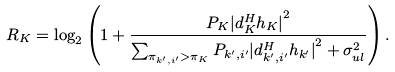Convert formula to latex. <formula><loc_0><loc_0><loc_500><loc_500>R _ { K } = \log _ { 2 } \left ( 1 + \frac { P _ { K } { | d _ { K } ^ { H } h _ { K } | } ^ { 2 } } { \sum _ { \pi _ { k ^ { \prime } , i ^ { \prime } } > \pi _ { K } } P _ { k ^ { \prime } , i ^ { \prime } } { | d _ { k ^ { \prime } , i ^ { \prime } } ^ { H } h _ { k ^ { \prime } } | } ^ { 2 } + \sigma _ { u l } ^ { 2 } } \right ) .</formula> 